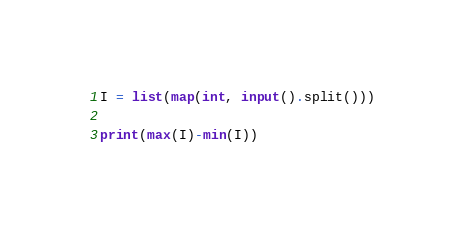<code> <loc_0><loc_0><loc_500><loc_500><_Python_>I = list(map(int, input().split()))

print(max(I)-min(I))</code> 